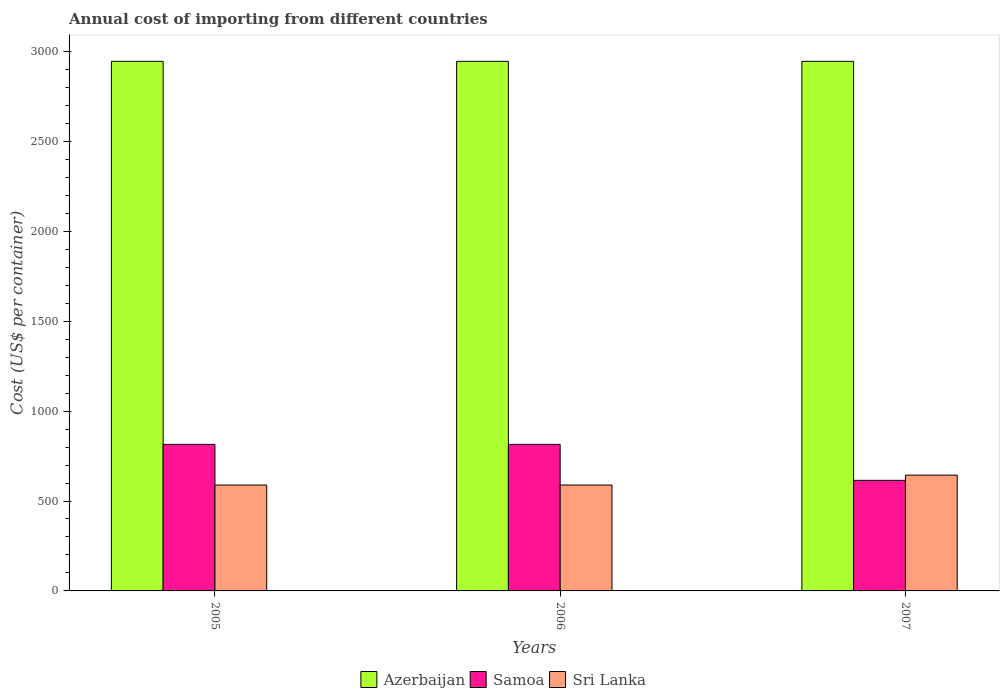How many different coloured bars are there?
Your answer should be very brief. 3. How many groups of bars are there?
Give a very brief answer. 3. How many bars are there on the 2nd tick from the left?
Provide a short and direct response. 3. How many bars are there on the 1st tick from the right?
Give a very brief answer. 3. What is the label of the 1st group of bars from the left?
Offer a very short reply. 2005. What is the total annual cost of importing in Sri Lanka in 2005?
Provide a short and direct response. 589. Across all years, what is the maximum total annual cost of importing in Sri Lanka?
Provide a succinct answer. 644. Across all years, what is the minimum total annual cost of importing in Azerbaijan?
Keep it short and to the point. 2945. In which year was the total annual cost of importing in Samoa maximum?
Your answer should be very brief. 2005. What is the total total annual cost of importing in Azerbaijan in the graph?
Your answer should be very brief. 8835. What is the difference between the total annual cost of importing in Sri Lanka in 2005 and that in 2007?
Provide a succinct answer. -55. What is the difference between the total annual cost of importing in Sri Lanka in 2007 and the total annual cost of importing in Samoa in 2005?
Provide a short and direct response. -171. What is the average total annual cost of importing in Azerbaijan per year?
Ensure brevity in your answer.  2945. In the year 2006, what is the difference between the total annual cost of importing in Azerbaijan and total annual cost of importing in Sri Lanka?
Provide a short and direct response. 2356. In how many years, is the total annual cost of importing in Sri Lanka greater than 500 US$?
Make the answer very short. 3. Is the total annual cost of importing in Azerbaijan in 2006 less than that in 2007?
Keep it short and to the point. No. Is the difference between the total annual cost of importing in Azerbaijan in 2005 and 2007 greater than the difference between the total annual cost of importing in Sri Lanka in 2005 and 2007?
Your answer should be very brief. Yes. What is the difference between the highest and the lowest total annual cost of importing in Sri Lanka?
Give a very brief answer. 55. Is the sum of the total annual cost of importing in Sri Lanka in 2006 and 2007 greater than the maximum total annual cost of importing in Azerbaijan across all years?
Offer a terse response. No. What does the 1st bar from the left in 2006 represents?
Your answer should be compact. Azerbaijan. What does the 3rd bar from the right in 2006 represents?
Your response must be concise. Azerbaijan. Is it the case that in every year, the sum of the total annual cost of importing in Azerbaijan and total annual cost of importing in Sri Lanka is greater than the total annual cost of importing in Samoa?
Offer a terse response. Yes. How many bars are there?
Ensure brevity in your answer.  9. How many years are there in the graph?
Offer a very short reply. 3. Does the graph contain grids?
Your answer should be compact. No. Where does the legend appear in the graph?
Offer a terse response. Bottom center. How many legend labels are there?
Your answer should be very brief. 3. How are the legend labels stacked?
Provide a succinct answer. Horizontal. What is the title of the graph?
Give a very brief answer. Annual cost of importing from different countries. What is the label or title of the X-axis?
Make the answer very short. Years. What is the label or title of the Y-axis?
Offer a terse response. Cost (US$ per container). What is the Cost (US$ per container) of Azerbaijan in 2005?
Offer a terse response. 2945. What is the Cost (US$ per container) of Samoa in 2005?
Give a very brief answer. 815. What is the Cost (US$ per container) in Sri Lanka in 2005?
Your answer should be compact. 589. What is the Cost (US$ per container) of Azerbaijan in 2006?
Your answer should be very brief. 2945. What is the Cost (US$ per container) in Samoa in 2006?
Ensure brevity in your answer.  815. What is the Cost (US$ per container) of Sri Lanka in 2006?
Make the answer very short. 589. What is the Cost (US$ per container) in Azerbaijan in 2007?
Your answer should be very brief. 2945. What is the Cost (US$ per container) of Samoa in 2007?
Keep it short and to the point. 615. What is the Cost (US$ per container) in Sri Lanka in 2007?
Your answer should be very brief. 644. Across all years, what is the maximum Cost (US$ per container) in Azerbaijan?
Offer a very short reply. 2945. Across all years, what is the maximum Cost (US$ per container) in Samoa?
Make the answer very short. 815. Across all years, what is the maximum Cost (US$ per container) in Sri Lanka?
Give a very brief answer. 644. Across all years, what is the minimum Cost (US$ per container) in Azerbaijan?
Your response must be concise. 2945. Across all years, what is the minimum Cost (US$ per container) in Samoa?
Your response must be concise. 615. Across all years, what is the minimum Cost (US$ per container) in Sri Lanka?
Provide a succinct answer. 589. What is the total Cost (US$ per container) in Azerbaijan in the graph?
Keep it short and to the point. 8835. What is the total Cost (US$ per container) in Samoa in the graph?
Your answer should be compact. 2245. What is the total Cost (US$ per container) in Sri Lanka in the graph?
Provide a succinct answer. 1822. What is the difference between the Cost (US$ per container) in Samoa in 2005 and that in 2006?
Keep it short and to the point. 0. What is the difference between the Cost (US$ per container) in Sri Lanka in 2005 and that in 2006?
Provide a short and direct response. 0. What is the difference between the Cost (US$ per container) in Samoa in 2005 and that in 2007?
Your response must be concise. 200. What is the difference between the Cost (US$ per container) in Sri Lanka in 2005 and that in 2007?
Your response must be concise. -55. What is the difference between the Cost (US$ per container) of Sri Lanka in 2006 and that in 2007?
Provide a succinct answer. -55. What is the difference between the Cost (US$ per container) of Azerbaijan in 2005 and the Cost (US$ per container) of Samoa in 2006?
Provide a succinct answer. 2130. What is the difference between the Cost (US$ per container) of Azerbaijan in 2005 and the Cost (US$ per container) of Sri Lanka in 2006?
Offer a terse response. 2356. What is the difference between the Cost (US$ per container) in Samoa in 2005 and the Cost (US$ per container) in Sri Lanka in 2006?
Your answer should be compact. 226. What is the difference between the Cost (US$ per container) in Azerbaijan in 2005 and the Cost (US$ per container) in Samoa in 2007?
Provide a short and direct response. 2330. What is the difference between the Cost (US$ per container) in Azerbaijan in 2005 and the Cost (US$ per container) in Sri Lanka in 2007?
Make the answer very short. 2301. What is the difference between the Cost (US$ per container) in Samoa in 2005 and the Cost (US$ per container) in Sri Lanka in 2007?
Offer a terse response. 171. What is the difference between the Cost (US$ per container) of Azerbaijan in 2006 and the Cost (US$ per container) of Samoa in 2007?
Your answer should be very brief. 2330. What is the difference between the Cost (US$ per container) of Azerbaijan in 2006 and the Cost (US$ per container) of Sri Lanka in 2007?
Give a very brief answer. 2301. What is the difference between the Cost (US$ per container) in Samoa in 2006 and the Cost (US$ per container) in Sri Lanka in 2007?
Provide a succinct answer. 171. What is the average Cost (US$ per container) of Azerbaijan per year?
Keep it short and to the point. 2945. What is the average Cost (US$ per container) of Samoa per year?
Offer a very short reply. 748.33. What is the average Cost (US$ per container) of Sri Lanka per year?
Your response must be concise. 607.33. In the year 2005, what is the difference between the Cost (US$ per container) in Azerbaijan and Cost (US$ per container) in Samoa?
Keep it short and to the point. 2130. In the year 2005, what is the difference between the Cost (US$ per container) in Azerbaijan and Cost (US$ per container) in Sri Lanka?
Keep it short and to the point. 2356. In the year 2005, what is the difference between the Cost (US$ per container) in Samoa and Cost (US$ per container) in Sri Lanka?
Make the answer very short. 226. In the year 2006, what is the difference between the Cost (US$ per container) in Azerbaijan and Cost (US$ per container) in Samoa?
Your answer should be very brief. 2130. In the year 2006, what is the difference between the Cost (US$ per container) in Azerbaijan and Cost (US$ per container) in Sri Lanka?
Give a very brief answer. 2356. In the year 2006, what is the difference between the Cost (US$ per container) in Samoa and Cost (US$ per container) in Sri Lanka?
Offer a very short reply. 226. In the year 2007, what is the difference between the Cost (US$ per container) in Azerbaijan and Cost (US$ per container) in Samoa?
Provide a succinct answer. 2330. In the year 2007, what is the difference between the Cost (US$ per container) of Azerbaijan and Cost (US$ per container) of Sri Lanka?
Offer a terse response. 2301. What is the ratio of the Cost (US$ per container) in Samoa in 2005 to that in 2007?
Offer a terse response. 1.33. What is the ratio of the Cost (US$ per container) in Sri Lanka in 2005 to that in 2007?
Offer a terse response. 0.91. What is the ratio of the Cost (US$ per container) in Azerbaijan in 2006 to that in 2007?
Your answer should be very brief. 1. What is the ratio of the Cost (US$ per container) in Samoa in 2006 to that in 2007?
Ensure brevity in your answer.  1.33. What is the ratio of the Cost (US$ per container) in Sri Lanka in 2006 to that in 2007?
Your answer should be very brief. 0.91. What is the difference between the highest and the second highest Cost (US$ per container) of Azerbaijan?
Make the answer very short. 0. What is the difference between the highest and the second highest Cost (US$ per container) of Samoa?
Ensure brevity in your answer.  0. What is the difference between the highest and the lowest Cost (US$ per container) in Azerbaijan?
Keep it short and to the point. 0. What is the difference between the highest and the lowest Cost (US$ per container) of Sri Lanka?
Make the answer very short. 55. 